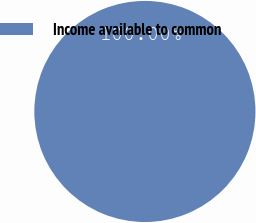Convert chart. <chart><loc_0><loc_0><loc_500><loc_500><pie_chart><fcel>Income available to common<nl><fcel>100.0%<nl></chart> 